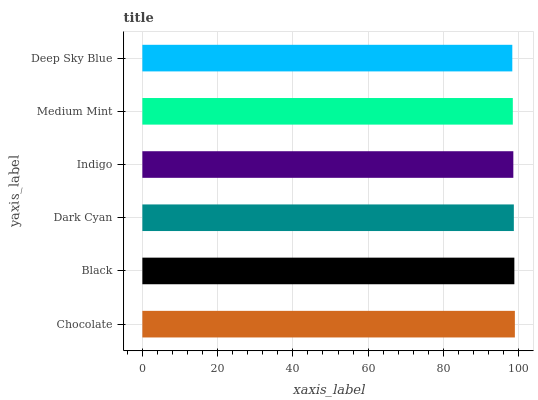Is Deep Sky Blue the minimum?
Answer yes or no. Yes. Is Chocolate the maximum?
Answer yes or no. Yes. Is Black the minimum?
Answer yes or no. No. Is Black the maximum?
Answer yes or no. No. Is Chocolate greater than Black?
Answer yes or no. Yes. Is Black less than Chocolate?
Answer yes or no. Yes. Is Black greater than Chocolate?
Answer yes or no. No. Is Chocolate less than Black?
Answer yes or no. No. Is Dark Cyan the high median?
Answer yes or no. Yes. Is Indigo the low median?
Answer yes or no. Yes. Is Deep Sky Blue the high median?
Answer yes or no. No. Is Dark Cyan the low median?
Answer yes or no. No. 